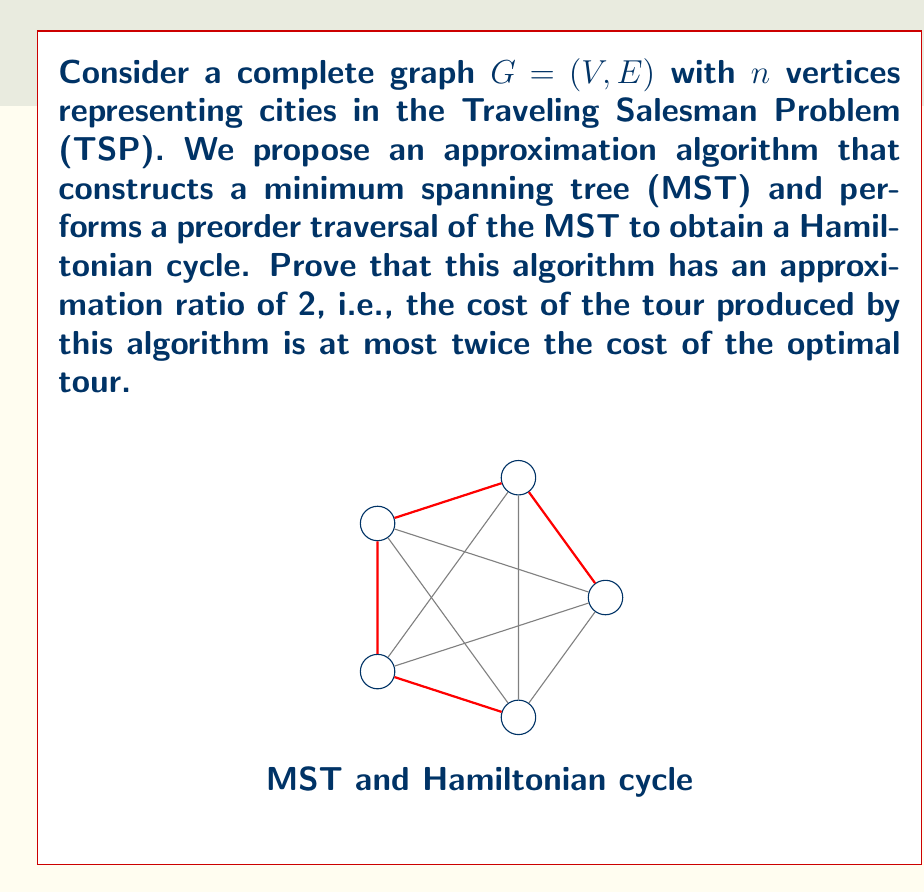Teach me how to tackle this problem. Let's approach this proof step-by-step:

1) Let $OPT$ be the cost of the optimal TSP tour, and $ALG$ be the cost of the tour produced by our algorithm.

2) Let $MST$ be the cost of the minimum spanning tree of $G$.

3) First, we prove that $MST \leq OPT$:
   - Consider the optimal TSP tour and remove any edge from it.
   - The resulting path is a spanning tree of $G$.
   - Since MST is the minimum spanning tree, its cost must be less than or equal to this path.
   - Therefore, $MST \leq OPT$.

4) Now, let's consider the preorder traversal of the MST:
   - This traversal visits each edge of the MST exactly twice (once going down, once going up).
   - Therefore, the cost of this traversal is $2 \cdot MST$.

5) Our algorithm creates a Hamiltonian cycle from this traversal by skipping repeated visits:
   - Due to the triangle inequality (which is assumed in metric TSP), skipping vertices can only decrease the total distance.
   - Thus, $ALG \leq 2 \cdot MST$.

6) Combining the inequalities from steps 3 and 5:
   $ALG \leq 2 \cdot MST \leq 2 \cdot OPT$

7) Therefore, $\frac{ALG}{OPT} \leq 2$, which proves that the approximation ratio is at most 2.

This algorithm is known as the Minimum Spanning Tree Heuristic for TSP.
Answer: The approximation ratio is 2. 